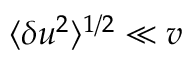Convert formula to latex. <formula><loc_0><loc_0><loc_500><loc_500>\langle \delta u ^ { 2 } \rangle ^ { 1 / 2 } \ll v</formula> 